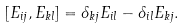Convert formula to latex. <formula><loc_0><loc_0><loc_500><loc_500>[ E _ { i j } , E _ { k l } ] = \delta _ { k j } E _ { i l } - \delta _ { i l } E _ { k j } .</formula> 